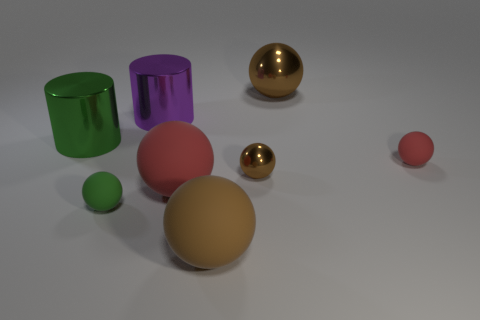Are there fewer purple metal cylinders than large blue rubber cubes?
Your answer should be very brief. No. Does the big ball in front of the small green rubber thing have the same color as the small metallic sphere?
Offer a terse response. Yes. The other tiny object that is the same material as the small red object is what color?
Your answer should be compact. Green. Do the brown rubber ball and the green metal cylinder have the same size?
Keep it short and to the point. Yes. What is the material of the purple cylinder?
Your response must be concise. Metal. There is a red ball that is the same size as the green matte thing; what is its material?
Keep it short and to the point. Rubber. Are there any brown matte things of the same size as the purple object?
Your answer should be very brief. Yes. Are there the same number of big purple shiny objects to the left of the big purple thing and large rubber balls that are on the right side of the tiny brown sphere?
Give a very brief answer. Yes. Are there more big green cylinders than big metallic objects?
Provide a short and direct response. No. How many shiny things are either big purple spheres or cylinders?
Make the answer very short. 2. 